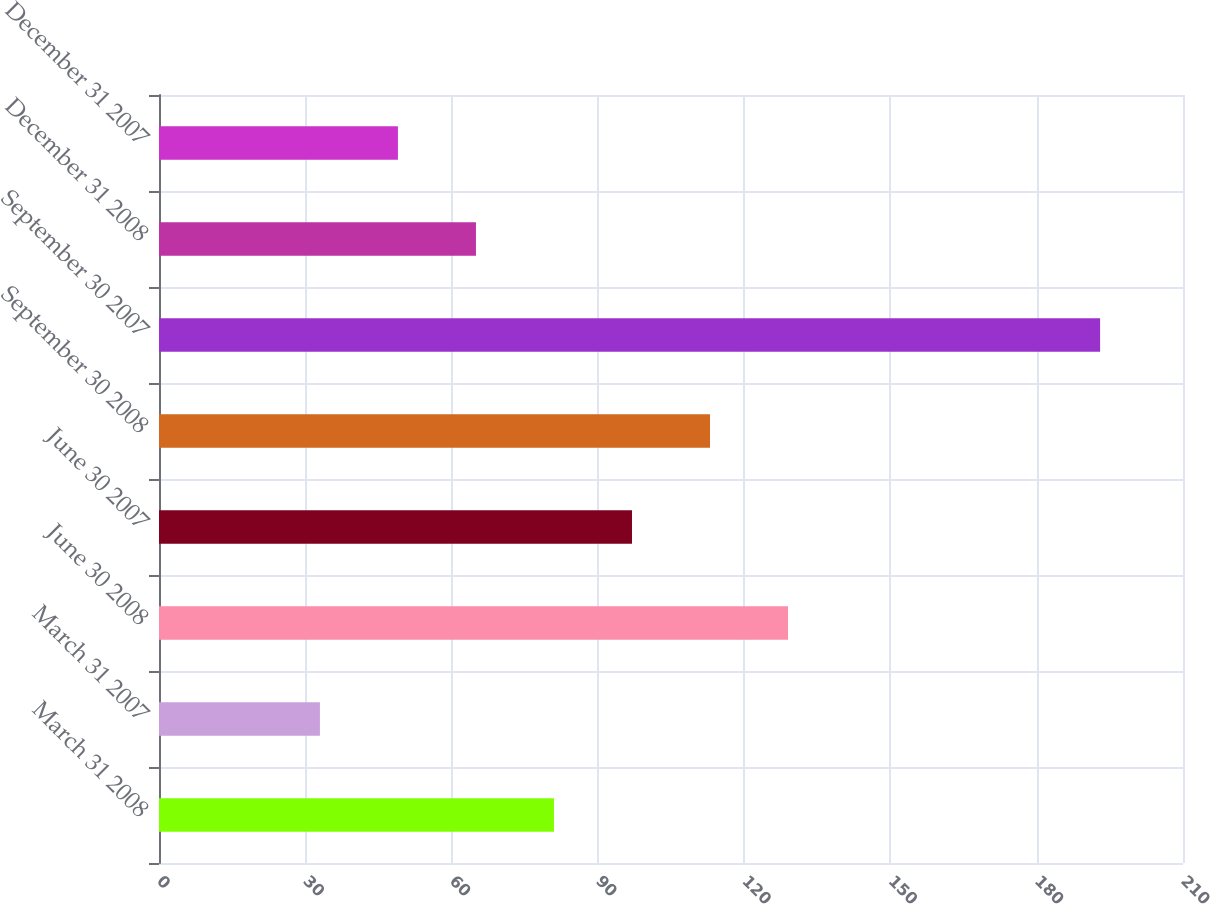Convert chart. <chart><loc_0><loc_0><loc_500><loc_500><bar_chart><fcel>March 31 2008<fcel>March 31 2007<fcel>June 30 2008<fcel>June 30 2007<fcel>September 30 2008<fcel>September 30 2007<fcel>December 31 2008<fcel>December 31 2007<nl><fcel>81<fcel>33<fcel>129<fcel>97<fcel>113<fcel>193<fcel>65<fcel>49<nl></chart> 